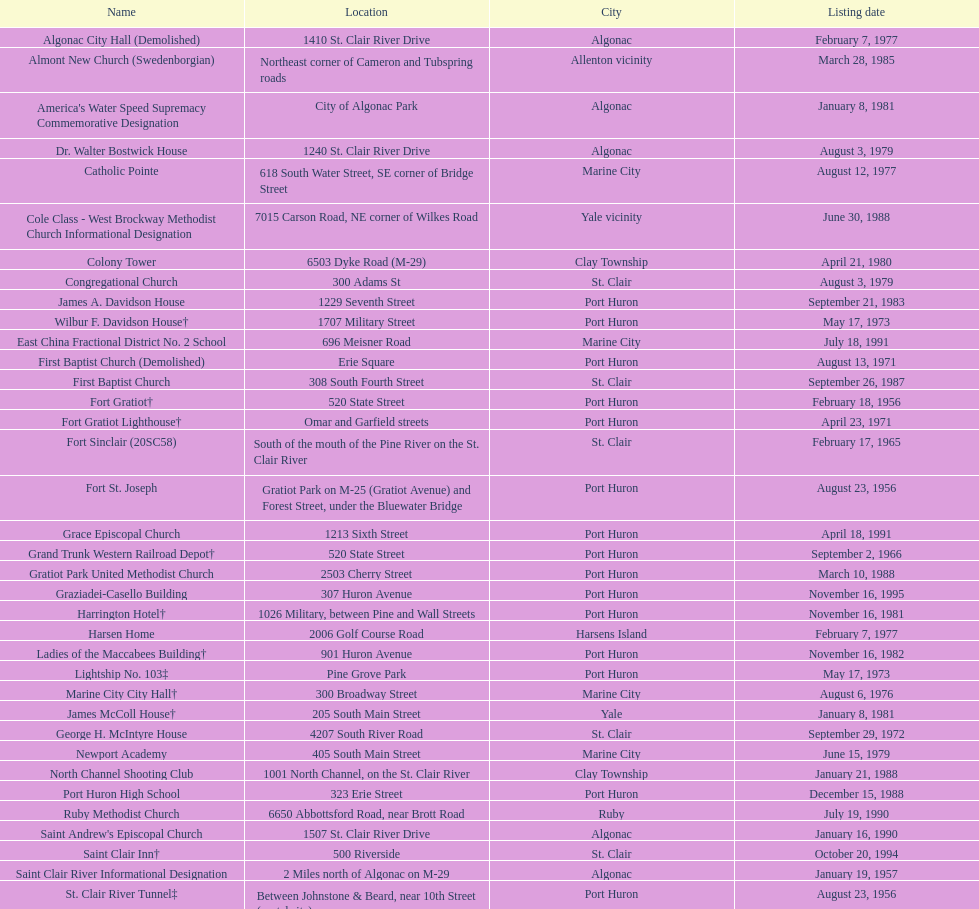Fort gratiot lighthouse and fort st. joseph are situated in which city? Port Huron. 